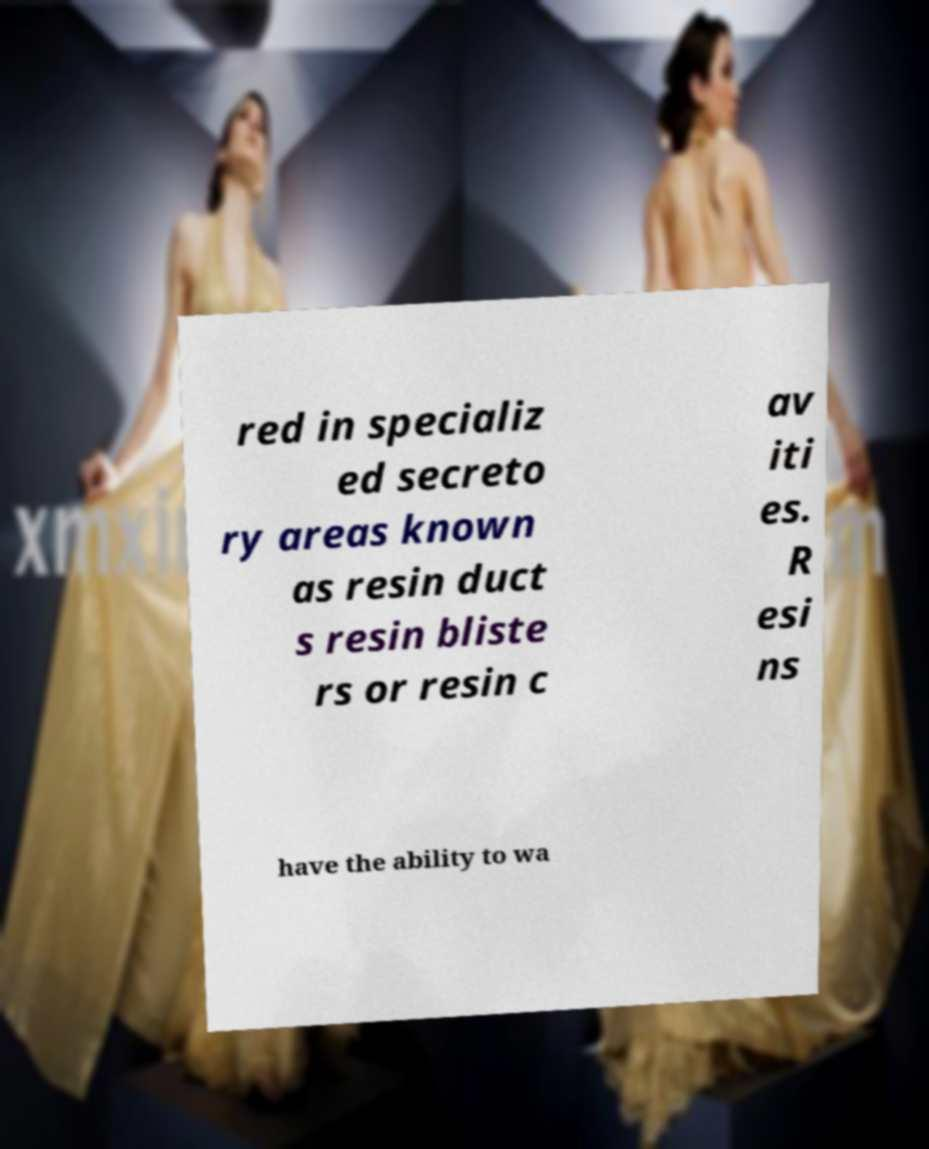Could you assist in decoding the text presented in this image and type it out clearly? red in specializ ed secreto ry areas known as resin duct s resin bliste rs or resin c av iti es. R esi ns have the ability to wa 